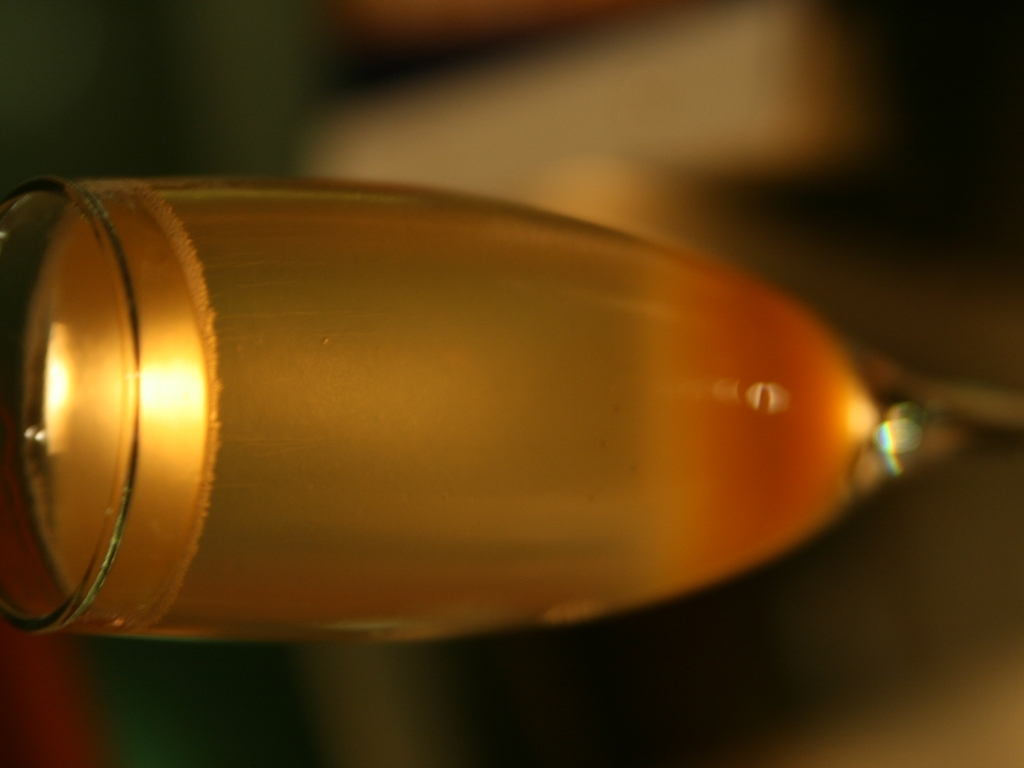Is there anything notable about the colors or the lighting in this image? The image has a warm color palette with gentle lighting that creates a soft glow on the glass and its contents. This sort of lighting can convey a feeling of coziness or intimacy and may even suggest a certain time of day, like the evening. What can you infer about the setting or the mood of where this photo might have been taken? Given the warm lighting and the composition, one might infer that the photo was taken in a serene setting, perhaps during a relaxed moment like a dinner at home or in a restaurant with a quiet ambiance. The mood seems tranquil and inviting. 